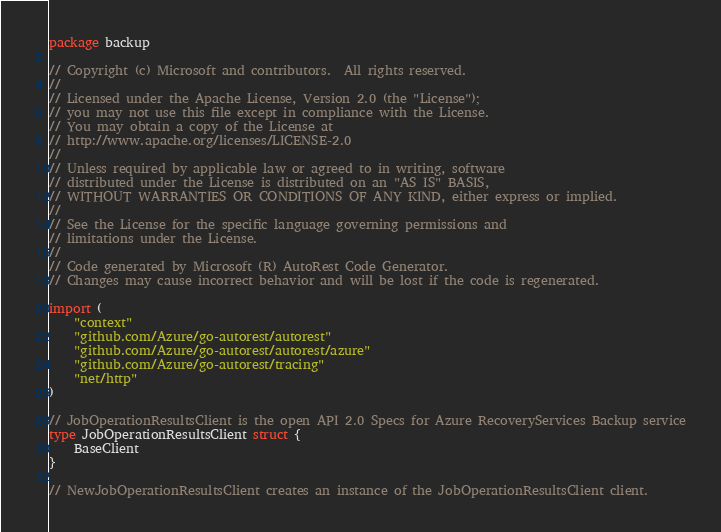<code> <loc_0><loc_0><loc_500><loc_500><_Go_>package backup

// Copyright (c) Microsoft and contributors.  All rights reserved.
//
// Licensed under the Apache License, Version 2.0 (the "License");
// you may not use this file except in compliance with the License.
// You may obtain a copy of the License at
// http://www.apache.org/licenses/LICENSE-2.0
//
// Unless required by applicable law or agreed to in writing, software
// distributed under the License is distributed on an "AS IS" BASIS,
// WITHOUT WARRANTIES OR CONDITIONS OF ANY KIND, either express or implied.
//
// See the License for the specific language governing permissions and
// limitations under the License.
//
// Code generated by Microsoft (R) AutoRest Code Generator.
// Changes may cause incorrect behavior and will be lost if the code is regenerated.

import (
	"context"
	"github.com/Azure/go-autorest/autorest"
	"github.com/Azure/go-autorest/autorest/azure"
	"github.com/Azure/go-autorest/tracing"
	"net/http"
)

// JobOperationResultsClient is the open API 2.0 Specs for Azure RecoveryServices Backup service
type JobOperationResultsClient struct {
	BaseClient
}

// NewJobOperationResultsClient creates an instance of the JobOperationResultsClient client.</code> 